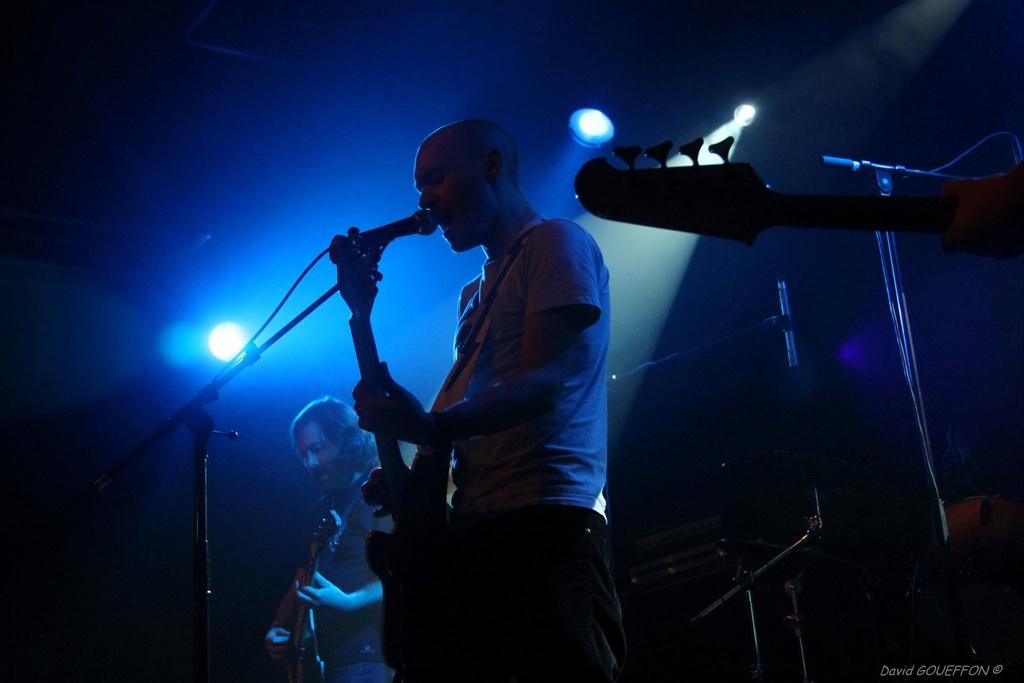How many people are in the image? There are two persons in the image. Where are the two persons located? The two persons are standing on a stage. What are the two persons doing on the stage? The persons are playing musical instruments. What can be seen in the background of the image? There is a light visible in the background of the image. What type of credit can be seen on the musical instruments in the image? There is no credit visible on the musical instruments in the image. How does the form of the stage affect the sound of the musical instruments? The image does not provide information about the form of the stage, so it is impossible to determine how it might affect the sound of the musical instruments. 